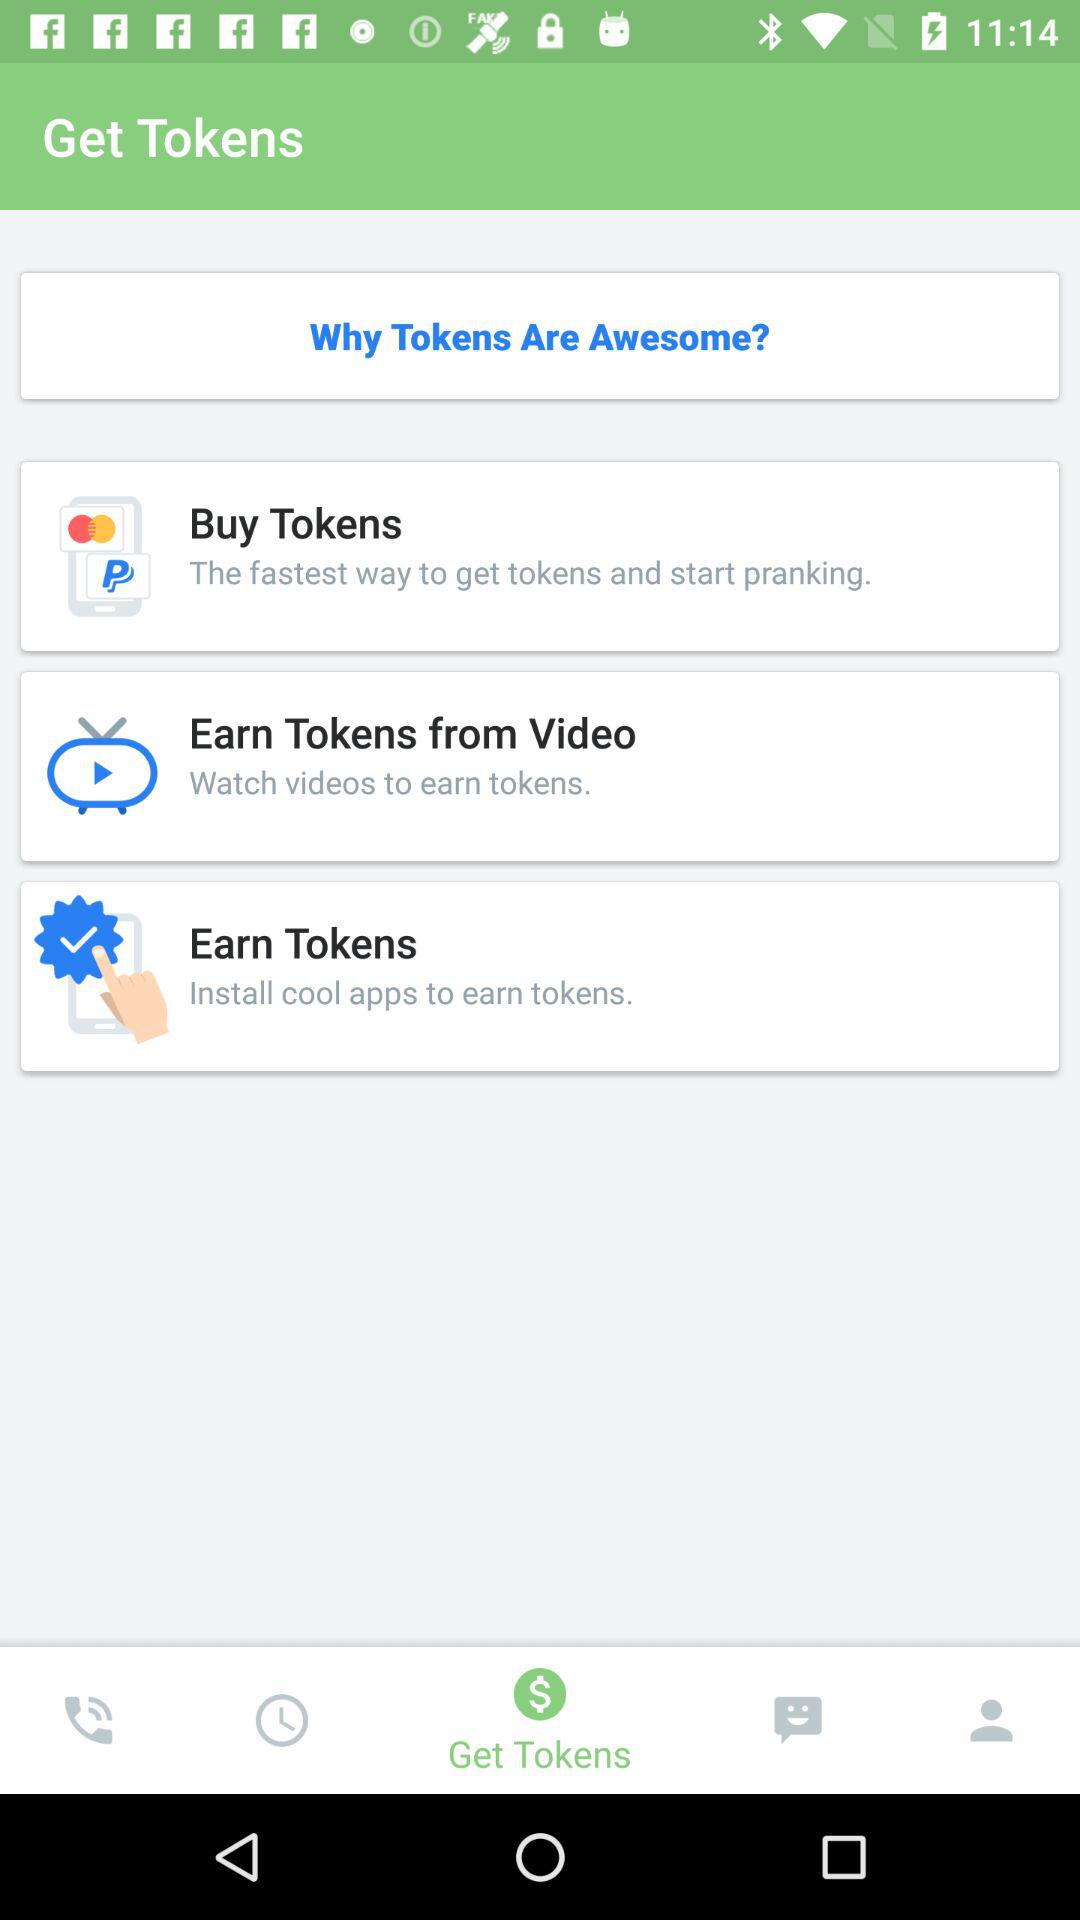How many ways can I earn tokens?
Answer the question using a single word or phrase. 3 